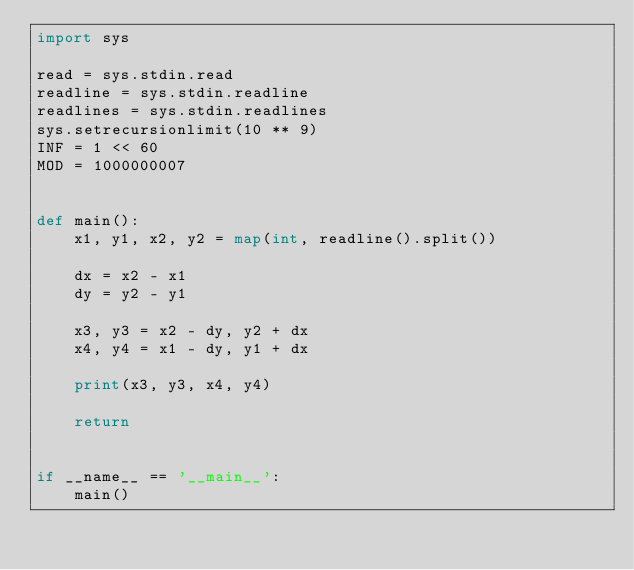<code> <loc_0><loc_0><loc_500><loc_500><_Python_>import sys

read = sys.stdin.read
readline = sys.stdin.readline
readlines = sys.stdin.readlines
sys.setrecursionlimit(10 ** 9)
INF = 1 << 60
MOD = 1000000007


def main():
    x1, y1, x2, y2 = map(int, readline().split())
    
    dx = x2 - x1
    dy = y2 - y1
    
    x3, y3 = x2 - dy, y2 + dx
    x4, y4 = x1 - dy, y1 + dx
    
    print(x3, y3, x4, y4)
    
    return


if __name__ == '__main__':
    main()
</code> 